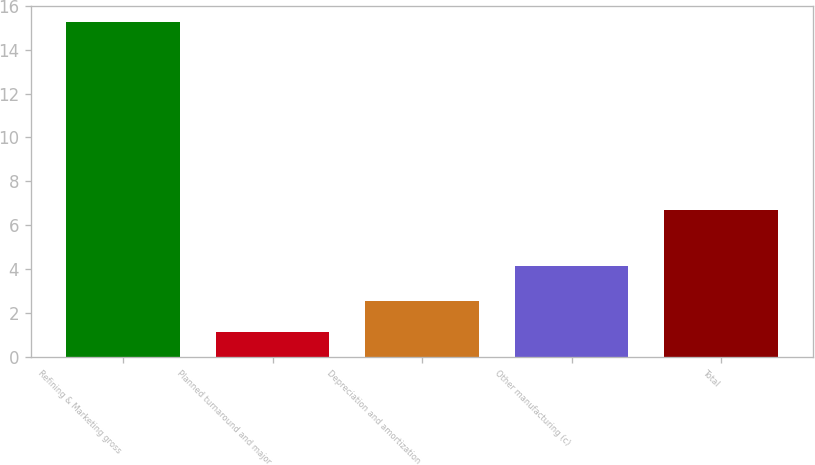Convert chart to OTSL. <chart><loc_0><loc_0><loc_500><loc_500><bar_chart><fcel>Refining & Marketing gross<fcel>Planned turnaround and major<fcel>Depreciation and amortization<fcel>Other manufacturing (c)<fcel>Total<nl><fcel>15.25<fcel>1.13<fcel>2.54<fcel>4.15<fcel>6.67<nl></chart> 